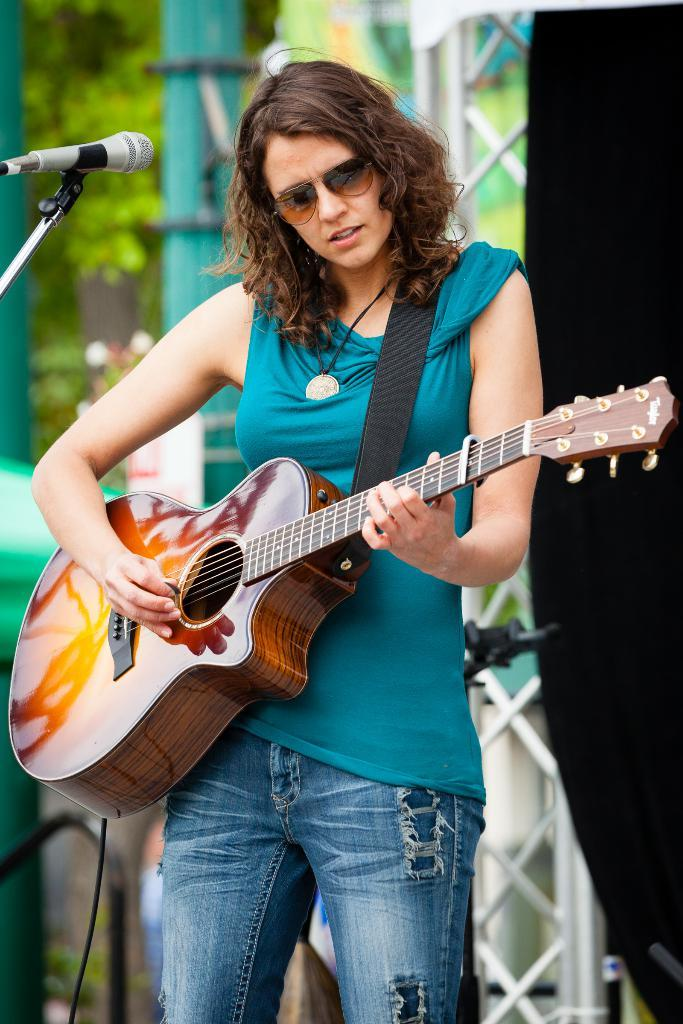Who is the main subject in the image? There is a woman in the image. What is the woman wearing? The woman is wearing a green dress. What is the woman doing in the image? The woman is playing a guitar. What object is present that might be used for amplifying her voice? There is a microphone in the image. How many cherries are on the woman's guitar in the image? There are no cherries present on the woman's guitar in the image. What emotion does the woman express towards the audience in the image? The image does not convey any specific emotion or sentiment from the woman towards the audience. 